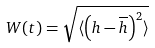Convert formula to latex. <formula><loc_0><loc_0><loc_500><loc_500>W ( t ) = \sqrt { \langle \left ( h - \overline { h } \right ) ^ { 2 } \rangle }</formula> 